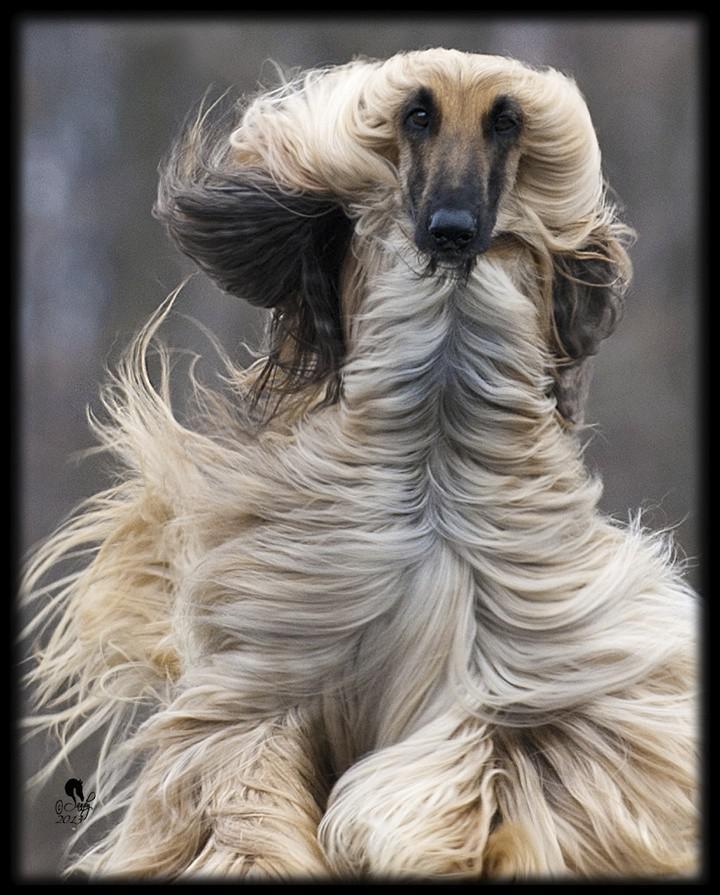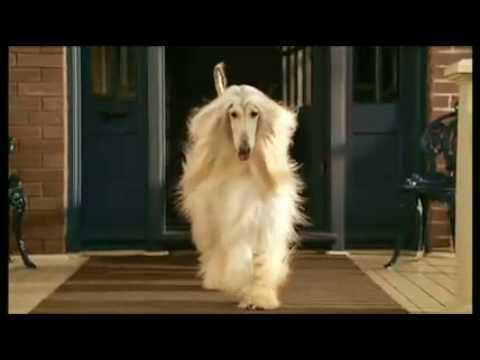The first image is the image on the left, the second image is the image on the right. Assess this claim about the two images: "An image includes a dog wearing something that covers its neck and the top of its head.". Correct or not? Answer yes or no. No. The first image is the image on the left, the second image is the image on the right. Considering the images on both sides, is "In one image, one or more dogs with a long snout and black nose is wearing a head covering that extends down the neck, while a single dog in the second image is bareheaded." valid? Answer yes or no. No. 